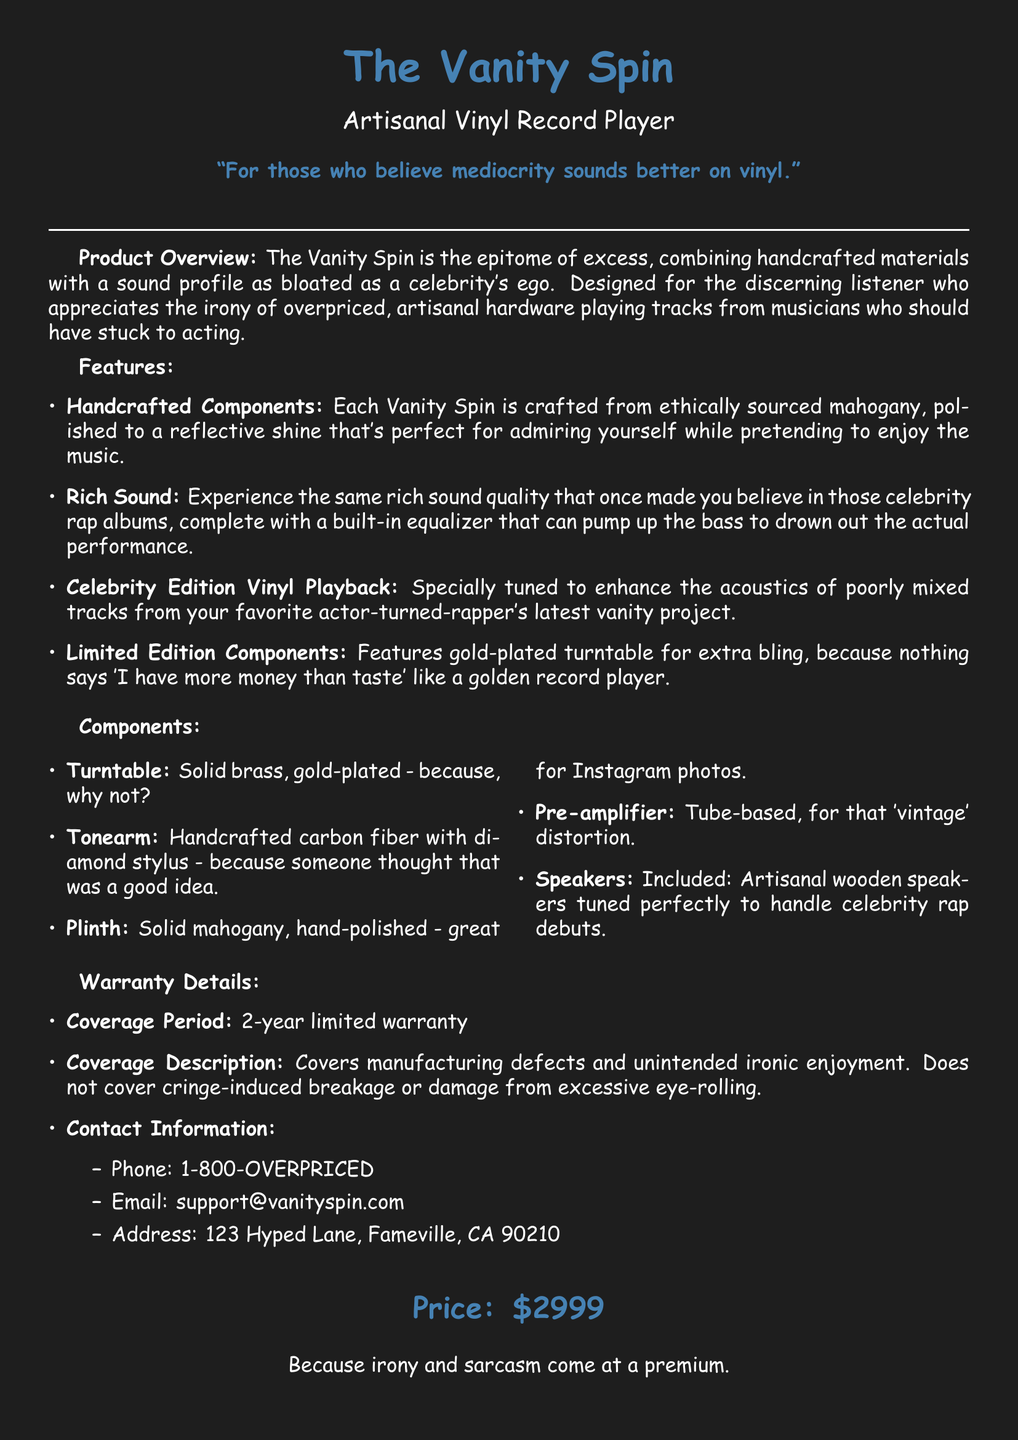what is the price of the product? The price of the Vanity Spin is stated clearly in the document.
Answer: $2999 what type of components are used in the turntable? The document mentions the material used for the turntable component.
Answer: gold-plated brass how long is the warranty coverage period? The coverage period is specifically mentioned in the warranty details section.
Answer: 2 years what is the unique feature of the vinyl playback? The document highlights a special tuning related to vinyl playback.
Answer: Celebrity Edition what material is the plinth made of? The document lists the material for the plinth component.
Answer: solid mahogany what does the warranty not cover? The warranty coverage description specifies certain exclusions.
Answer: cringe-induced breakage how many speakers are included with the product? The document states the speaker inclusion in the components section.
Answer: Included what is the purpose of the built-in equalizer? The document describes the function of the equalizer in relation to sound quality.
Answer: pump up the bass what is the aesthetic purpose of the hand-polished finish? The document suggests a reason behind the hand-polished finish of the plinth.
Answer: great for Instagram photos 